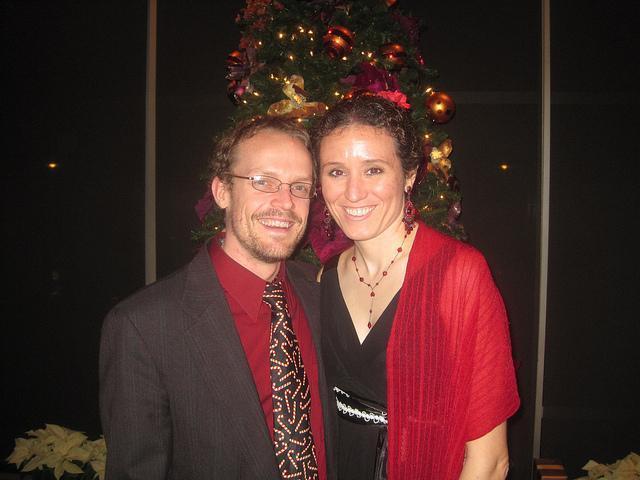How many strands are on the girls necklace?
Give a very brief answer. 1. How many Christmas trees are in the background?
Give a very brief answer. 1. How many people are visible?
Give a very brief answer. 2. How many of the tracks have a train on them?
Give a very brief answer. 0. 